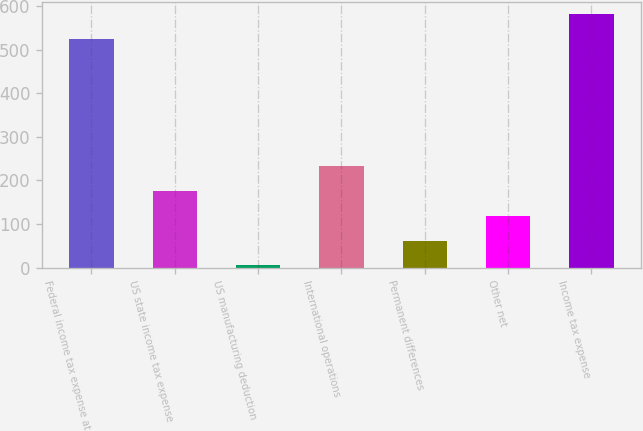Convert chart to OTSL. <chart><loc_0><loc_0><loc_500><loc_500><bar_chart><fcel>Federal income tax expense at<fcel>US state income tax expense<fcel>US manufacturing deduction<fcel>International operations<fcel>Permanent differences<fcel>Other net<fcel>Income tax expense<nl><fcel>524<fcel>176<fcel>5<fcel>233<fcel>62<fcel>119<fcel>581<nl></chart> 